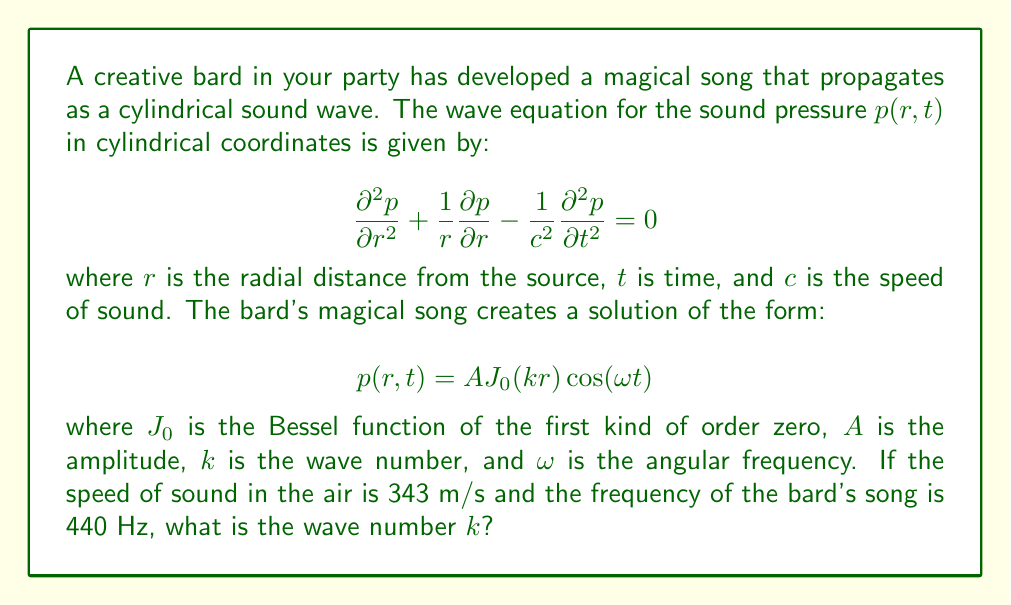What is the answer to this math problem? To solve this problem, we'll follow these steps:

1) First, recall that for a wave equation, the relationship between angular frequency $\omega$, wave number $k$, and speed of sound $c$ is:

   $$\omega = ck$$

2) We're given the frequency $f = 440$ Hz. We need to convert this to angular frequency $\omega$:

   $$\omega = 2\pi f = 2\pi(440) \approx 2763.89 \text{ rad/s}$$

3) We're also given the speed of sound $c = 343$ m/s.

4) Now we can use the relationship from step 1 to find $k$:

   $$k = \frac{\omega}{c} = \frac{2763.89}{343} \approx 8.0580 \text{ m}^{-1}$$

5) This value of $k$ ensures that the given solution satisfies the wave equation. You can verify this by substituting the solution back into the wave equation:

   $$\frac{\partial^2 p}{\partial r^2} = -Ak^2J_0(kr)\cos(\omega t)$$
   $$\frac{1}{r}\frac{\partial p}{\partial r} = -Ak\frac{J_1(kr)}{r}\cos(\omega t)$$
   $$\frac{\partial^2 p}{\partial t^2} = -A\omega^2J_0(kr)\cos(\omega t)$$

   Using the property of Bessel functions that $J_0''(x) + \frac{1}{x}J_0'(x) = -J_0(x)$, you can show that these terms satisfy the wave equation when $\omega = ck$.
Answer: $k \approx 8.0580 \text{ m}^{-1}$ 